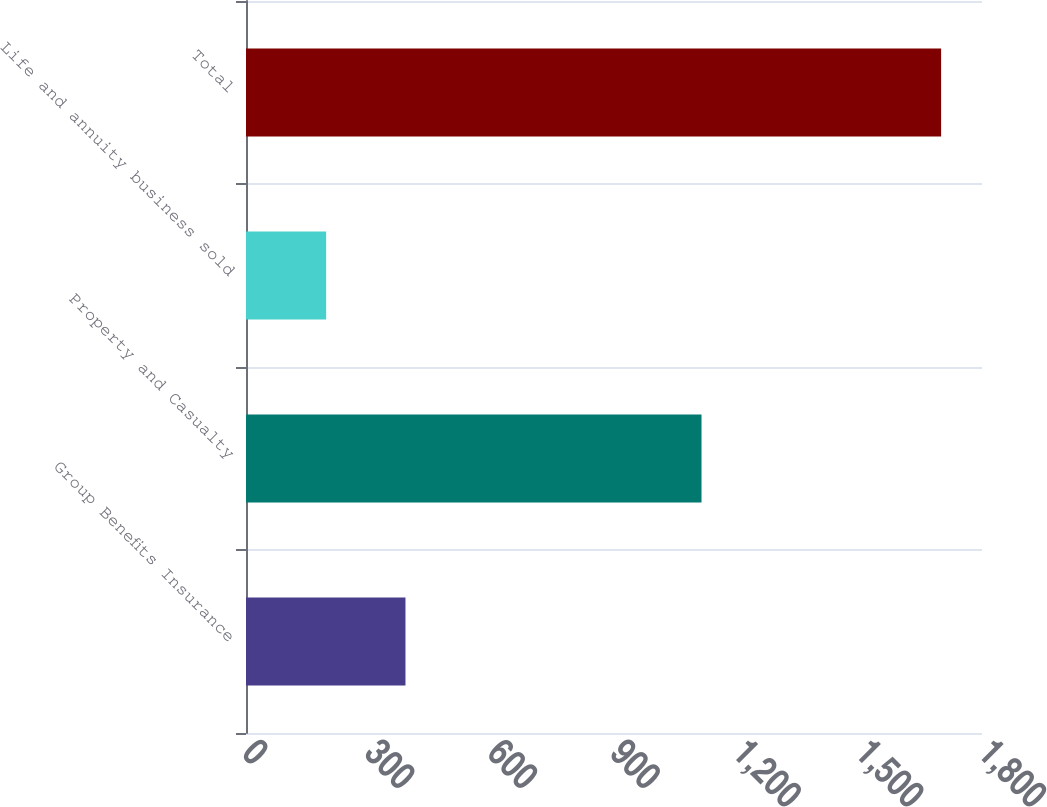Convert chart. <chart><loc_0><loc_0><loc_500><loc_500><bar_chart><fcel>Group Benefits Insurance<fcel>Property and Casualty<fcel>Life and annuity business sold<fcel>Total<nl><fcel>390<fcel>1114<fcel>196<fcel>1700<nl></chart> 